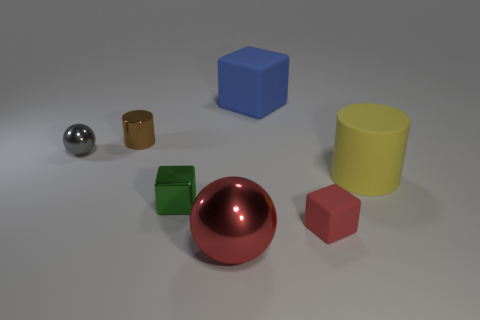There is a tiny green object that is the same material as the gray sphere; what shape is it?
Your response must be concise. Cube. What number of metallic things are either large blue objects or red cubes?
Provide a succinct answer. 0. Are there an equal number of big rubber cubes on the left side of the green thing and big cyan matte things?
Your answer should be compact. Yes. Is the color of the metal thing that is behind the gray shiny object the same as the small rubber block?
Give a very brief answer. No. What is the material of the object that is both in front of the yellow rubber cylinder and left of the red sphere?
Offer a very short reply. Metal. Are there any tiny objects that are on the right side of the large rubber thing that is to the left of the small red matte block?
Offer a very short reply. Yes. Are the green object and the large red thing made of the same material?
Offer a very short reply. Yes. The shiny object that is behind the red ball and to the right of the shiny cylinder has what shape?
Offer a very short reply. Cube. There is a sphere that is in front of the matte thing in front of the small metal cube; how big is it?
Offer a very short reply. Large. How many green shiny objects are the same shape as the red matte object?
Your answer should be compact. 1. 